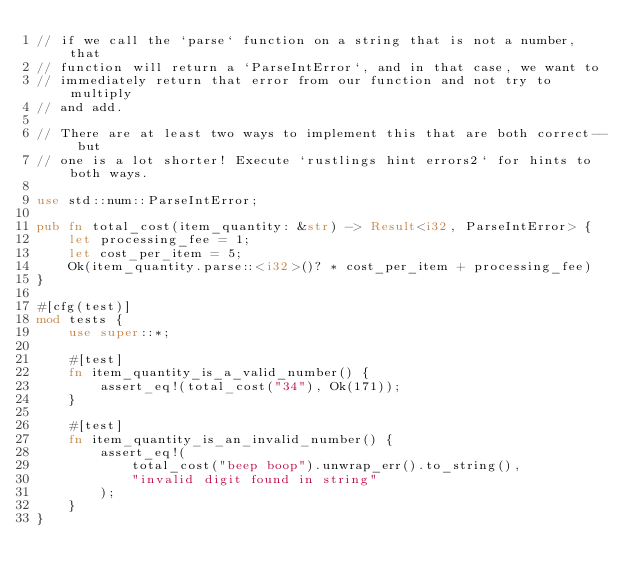<code> <loc_0><loc_0><loc_500><loc_500><_Rust_>// if we call the `parse` function on a string that is not a number, that
// function will return a `ParseIntError`, and in that case, we want to
// immediately return that error from our function and not try to multiply
// and add.

// There are at least two ways to implement this that are both correct-- but
// one is a lot shorter! Execute `rustlings hint errors2` for hints to both ways.

use std::num::ParseIntError;

pub fn total_cost(item_quantity: &str) -> Result<i32, ParseIntError> {
    let processing_fee = 1;
    let cost_per_item = 5;
    Ok(item_quantity.parse::<i32>()? * cost_per_item + processing_fee)
}

#[cfg(test)]
mod tests {
    use super::*;

    #[test]
    fn item_quantity_is_a_valid_number() {
        assert_eq!(total_cost("34"), Ok(171));
    }

    #[test]
    fn item_quantity_is_an_invalid_number() {
        assert_eq!(
            total_cost("beep boop").unwrap_err().to_string(),
            "invalid digit found in string"
        );
    }
}
</code> 